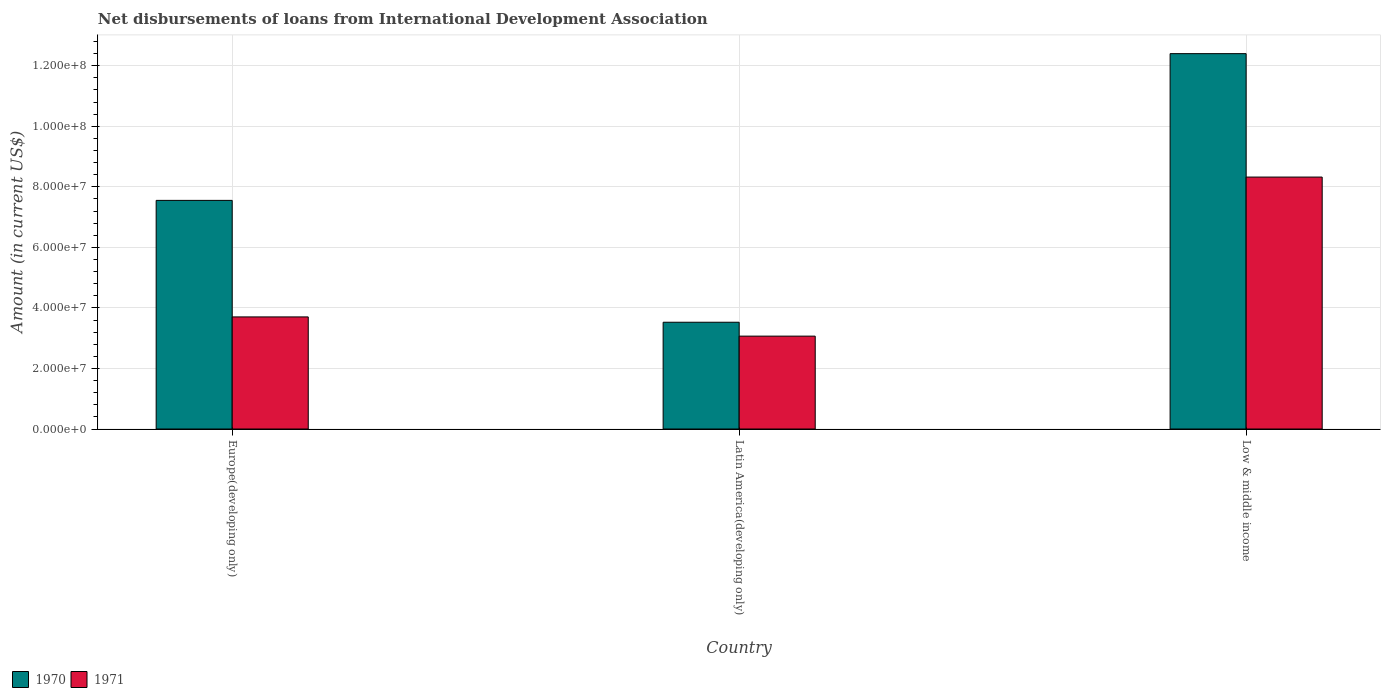How many groups of bars are there?
Give a very brief answer. 3. Are the number of bars per tick equal to the number of legend labels?
Give a very brief answer. Yes. Are the number of bars on each tick of the X-axis equal?
Ensure brevity in your answer.  Yes. How many bars are there on the 2nd tick from the left?
Ensure brevity in your answer.  2. How many bars are there on the 1st tick from the right?
Your answer should be compact. 2. In how many cases, is the number of bars for a given country not equal to the number of legend labels?
Offer a terse response. 0. What is the amount of loans disbursed in 1971 in Low & middle income?
Your response must be concise. 8.32e+07. Across all countries, what is the maximum amount of loans disbursed in 1970?
Give a very brief answer. 1.24e+08. Across all countries, what is the minimum amount of loans disbursed in 1970?
Offer a terse response. 3.53e+07. In which country was the amount of loans disbursed in 1971 maximum?
Your response must be concise. Low & middle income. In which country was the amount of loans disbursed in 1971 minimum?
Give a very brief answer. Latin America(developing only). What is the total amount of loans disbursed in 1970 in the graph?
Provide a succinct answer. 2.35e+08. What is the difference between the amount of loans disbursed in 1971 in Europe(developing only) and that in Low & middle income?
Your answer should be very brief. -4.62e+07. What is the difference between the amount of loans disbursed in 1971 in Europe(developing only) and the amount of loans disbursed in 1970 in Low & middle income?
Make the answer very short. -8.70e+07. What is the average amount of loans disbursed in 1971 per country?
Provide a short and direct response. 5.03e+07. What is the difference between the amount of loans disbursed of/in 1970 and amount of loans disbursed of/in 1971 in Latin America(developing only)?
Your answer should be very brief. 4.59e+06. What is the ratio of the amount of loans disbursed in 1971 in Europe(developing only) to that in Latin America(developing only)?
Your answer should be very brief. 1.21. Is the amount of loans disbursed in 1970 in Latin America(developing only) less than that in Low & middle income?
Ensure brevity in your answer.  Yes. What is the difference between the highest and the second highest amount of loans disbursed in 1970?
Your response must be concise. 4.85e+07. What is the difference between the highest and the lowest amount of loans disbursed in 1970?
Offer a very short reply. 8.87e+07. In how many countries, is the amount of loans disbursed in 1970 greater than the average amount of loans disbursed in 1970 taken over all countries?
Your answer should be very brief. 1. Is the sum of the amount of loans disbursed in 1970 in Europe(developing only) and Latin America(developing only) greater than the maximum amount of loans disbursed in 1971 across all countries?
Give a very brief answer. Yes. What does the 1st bar from the left in Latin America(developing only) represents?
Your response must be concise. 1970. What does the 1st bar from the right in Europe(developing only) represents?
Ensure brevity in your answer.  1971. Are all the bars in the graph horizontal?
Give a very brief answer. No. What is the difference between two consecutive major ticks on the Y-axis?
Provide a succinct answer. 2.00e+07. Are the values on the major ticks of Y-axis written in scientific E-notation?
Ensure brevity in your answer.  Yes. Does the graph contain any zero values?
Make the answer very short. No. How are the legend labels stacked?
Provide a succinct answer. Horizontal. What is the title of the graph?
Provide a short and direct response. Net disbursements of loans from International Development Association. What is the label or title of the X-axis?
Offer a very short reply. Country. What is the Amount (in current US$) in 1970 in Europe(developing only)?
Offer a very short reply. 7.55e+07. What is the Amount (in current US$) of 1971 in Europe(developing only)?
Offer a very short reply. 3.70e+07. What is the Amount (in current US$) of 1970 in Latin America(developing only)?
Your response must be concise. 3.53e+07. What is the Amount (in current US$) of 1971 in Latin America(developing only)?
Make the answer very short. 3.07e+07. What is the Amount (in current US$) in 1970 in Low & middle income?
Give a very brief answer. 1.24e+08. What is the Amount (in current US$) of 1971 in Low & middle income?
Offer a terse response. 8.32e+07. Across all countries, what is the maximum Amount (in current US$) in 1970?
Your answer should be compact. 1.24e+08. Across all countries, what is the maximum Amount (in current US$) of 1971?
Make the answer very short. 8.32e+07. Across all countries, what is the minimum Amount (in current US$) in 1970?
Offer a terse response. 3.53e+07. Across all countries, what is the minimum Amount (in current US$) of 1971?
Make the answer very short. 3.07e+07. What is the total Amount (in current US$) of 1970 in the graph?
Ensure brevity in your answer.  2.35e+08. What is the total Amount (in current US$) of 1971 in the graph?
Your answer should be very brief. 1.51e+08. What is the difference between the Amount (in current US$) in 1970 in Europe(developing only) and that in Latin America(developing only)?
Your response must be concise. 4.03e+07. What is the difference between the Amount (in current US$) of 1971 in Europe(developing only) and that in Latin America(developing only)?
Your answer should be very brief. 6.35e+06. What is the difference between the Amount (in current US$) of 1970 in Europe(developing only) and that in Low & middle income?
Your response must be concise. -4.85e+07. What is the difference between the Amount (in current US$) in 1971 in Europe(developing only) and that in Low & middle income?
Provide a short and direct response. -4.62e+07. What is the difference between the Amount (in current US$) in 1970 in Latin America(developing only) and that in Low & middle income?
Offer a terse response. -8.87e+07. What is the difference between the Amount (in current US$) of 1971 in Latin America(developing only) and that in Low & middle income?
Provide a succinct answer. -5.25e+07. What is the difference between the Amount (in current US$) in 1970 in Europe(developing only) and the Amount (in current US$) in 1971 in Latin America(developing only)?
Keep it short and to the point. 4.48e+07. What is the difference between the Amount (in current US$) of 1970 in Europe(developing only) and the Amount (in current US$) of 1971 in Low & middle income?
Your answer should be compact. -7.70e+06. What is the difference between the Amount (in current US$) in 1970 in Latin America(developing only) and the Amount (in current US$) in 1971 in Low & middle income?
Keep it short and to the point. -4.80e+07. What is the average Amount (in current US$) in 1970 per country?
Provide a succinct answer. 7.83e+07. What is the average Amount (in current US$) in 1971 per country?
Provide a short and direct response. 5.03e+07. What is the difference between the Amount (in current US$) in 1970 and Amount (in current US$) in 1971 in Europe(developing only)?
Provide a succinct answer. 3.85e+07. What is the difference between the Amount (in current US$) of 1970 and Amount (in current US$) of 1971 in Latin America(developing only)?
Your answer should be very brief. 4.59e+06. What is the difference between the Amount (in current US$) of 1970 and Amount (in current US$) of 1971 in Low & middle income?
Ensure brevity in your answer.  4.08e+07. What is the ratio of the Amount (in current US$) of 1970 in Europe(developing only) to that in Latin America(developing only)?
Your answer should be compact. 2.14. What is the ratio of the Amount (in current US$) of 1971 in Europe(developing only) to that in Latin America(developing only)?
Ensure brevity in your answer.  1.21. What is the ratio of the Amount (in current US$) in 1970 in Europe(developing only) to that in Low & middle income?
Provide a short and direct response. 0.61. What is the ratio of the Amount (in current US$) of 1971 in Europe(developing only) to that in Low & middle income?
Make the answer very short. 0.44. What is the ratio of the Amount (in current US$) of 1970 in Latin America(developing only) to that in Low & middle income?
Your response must be concise. 0.28. What is the ratio of the Amount (in current US$) in 1971 in Latin America(developing only) to that in Low & middle income?
Provide a short and direct response. 0.37. What is the difference between the highest and the second highest Amount (in current US$) of 1970?
Your answer should be very brief. 4.85e+07. What is the difference between the highest and the second highest Amount (in current US$) in 1971?
Provide a succinct answer. 4.62e+07. What is the difference between the highest and the lowest Amount (in current US$) in 1970?
Offer a terse response. 8.87e+07. What is the difference between the highest and the lowest Amount (in current US$) of 1971?
Your response must be concise. 5.25e+07. 